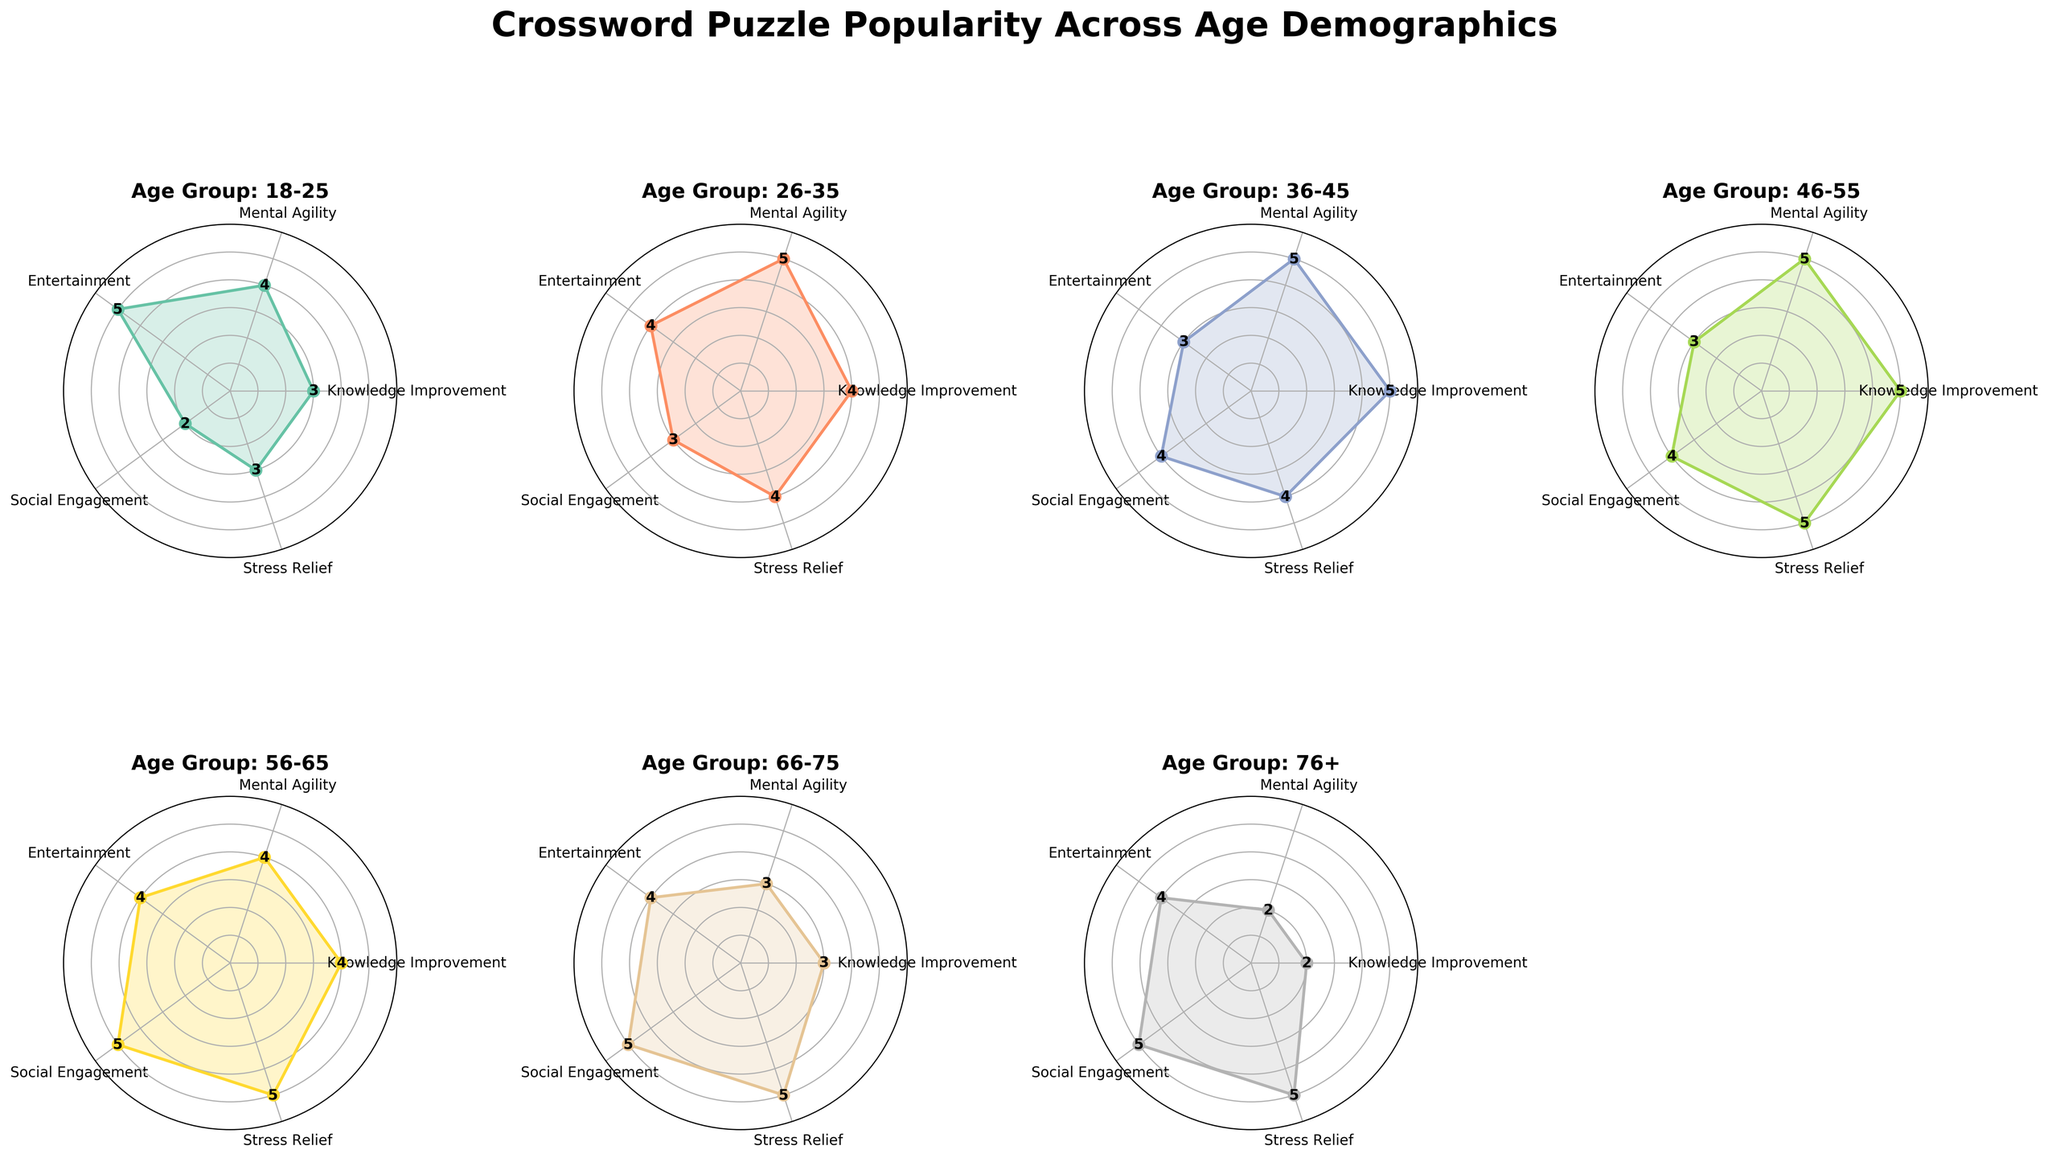What is the title of the figure? The title of the figure is generally placed at the top of the chart. In this case, it is stated as "Crossword Puzzle Popularity Across Age Demographics."
Answer: "Crossword Puzzle Popularity Across Age Demographics" How many radar charts are included in the figure? The figure has subplots for each age group detailed in the data provided, and there are 7 distinct age groups.
Answer: 7 Which age group shows the highest value for Mental Agility? The Mental Agility value is represented by one of the axes on the radar chart. By examining the charts, the age groups 26-35, 36-45, and 46-55 all show the highest value for Mental Agility, which is 5.
Answer: 26-35, 36-45, 46-55 Which age group shows the lowest value for Stress Relief, and what is that value? The Stress Relief value is also represented by one of the axes on the radar chart. By checking the values, the age group 18-25 shows the lowest value for Stress Relief, which is 3.
Answer: 18-25, 3 What is the average value of Knowledge Improvement across all age groups? Knowledge Improvement values are: 3, 4, 5, 5, 4, 3, and 2. Sum them up: (3 + 4 + 5 + 5 + 4 + 3 + 2) = 26, then divide by 7, the number of age groups. 26/7 ≈ 3.71.
Answer: 3.71 Which age group scores the highest for Social Engagement, and what is the value? Social Engagement is represented on one of the axes in each radar chart. The age groups 56-65, 66-75, and 76+ all score the highest for Social Engagement with a value of 5.
Answer: 56-65, 66-75, 76+, 5 Compare the Entertainment values between the age group 18-25 and 46-55. Which is higher and by how much? By examining the Entertainment values on the radar charts, the 18-25 age group has a score of 5 while the 46-55 age group has a score of 3. To find the difference: 5 - 3 = 2.
Answer: 18-25, 2 Which value sees a gradual decrease as the age group increases? By examining the radar charts, Mental Agility shows a gradual decrease across age groups, starting from a value of 4, reducing to 2 by the 76+ age group.
Answer: Mental Agility How many axes are there in each radar chart? Each radar chart consists of axes labelled Knowledge Improvement, Mental Agility, Entertainment, Social Engagement, and Stress Relief, making a total of 5 axes.
Answer: 5 